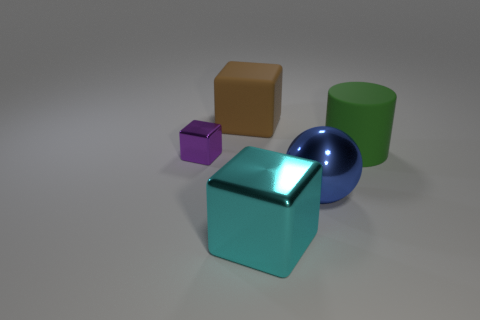Are the big block that is in front of the big ball and the cube that is to the left of the large matte cube made of the same material?
Offer a terse response. Yes. The large metal object that is behind the big cube in front of the green object is what shape?
Provide a short and direct response. Sphere. Are there any other things that have the same color as the large sphere?
Make the answer very short. No. Are there any large green things on the left side of the shiny block that is right of the shiny object behind the big blue object?
Your response must be concise. No. Does the cube in front of the small metallic object have the same color as the cube that is behind the small cube?
Provide a short and direct response. No. There is a blue thing that is the same size as the rubber cylinder; what material is it?
Provide a succinct answer. Metal. What is the size of the metallic cube that is right of the cube that is left of the cube that is behind the cylinder?
Keep it short and to the point. Large. How many other objects are there of the same material as the large blue thing?
Offer a terse response. 2. What is the size of the metal object that is left of the cyan metal block?
Offer a very short reply. Small. How many large objects are both on the right side of the rubber block and behind the big ball?
Offer a very short reply. 1. 